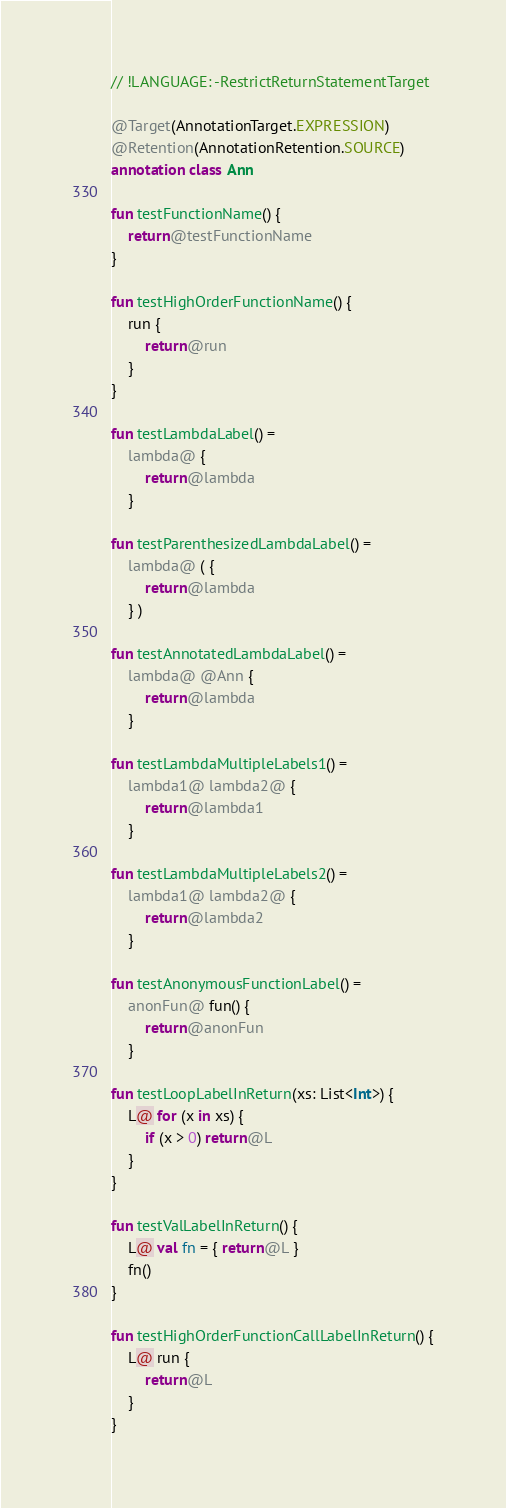Convert code to text. <code><loc_0><loc_0><loc_500><loc_500><_Kotlin_>// !LANGUAGE: -RestrictReturnStatementTarget

@Target(AnnotationTarget.EXPRESSION)
@Retention(AnnotationRetention.SOURCE)
annotation class Ann

fun testFunctionName() {
    return@testFunctionName
}

fun testHighOrderFunctionName() {
    run {
        return@run
    }
}

fun testLambdaLabel() =
    lambda@ {
        return@lambda
    }

fun testParenthesizedLambdaLabel() =
    lambda@ ( {
        return@lambda
    } )

fun testAnnotatedLambdaLabel() =
    lambda@ @Ann {
        return@lambda
    }

fun testLambdaMultipleLabels1() =
    lambda1@ lambda2@ {
        return@lambda1
    }

fun testLambdaMultipleLabels2() =
    lambda1@ lambda2@ {
        return@lambda2
    }

fun testAnonymousFunctionLabel() =
    anonFun@ fun() {
        return@anonFun
    }

fun testLoopLabelInReturn(xs: List<Int>) {
    L@ for (x in xs) {
        if (x > 0) return@L
    }
}

fun testValLabelInReturn() {
    L@ val fn = { return@L }
    fn()
}

fun testHighOrderFunctionCallLabelInReturn() {
    L@ run {
        return@L
    }
}</code> 